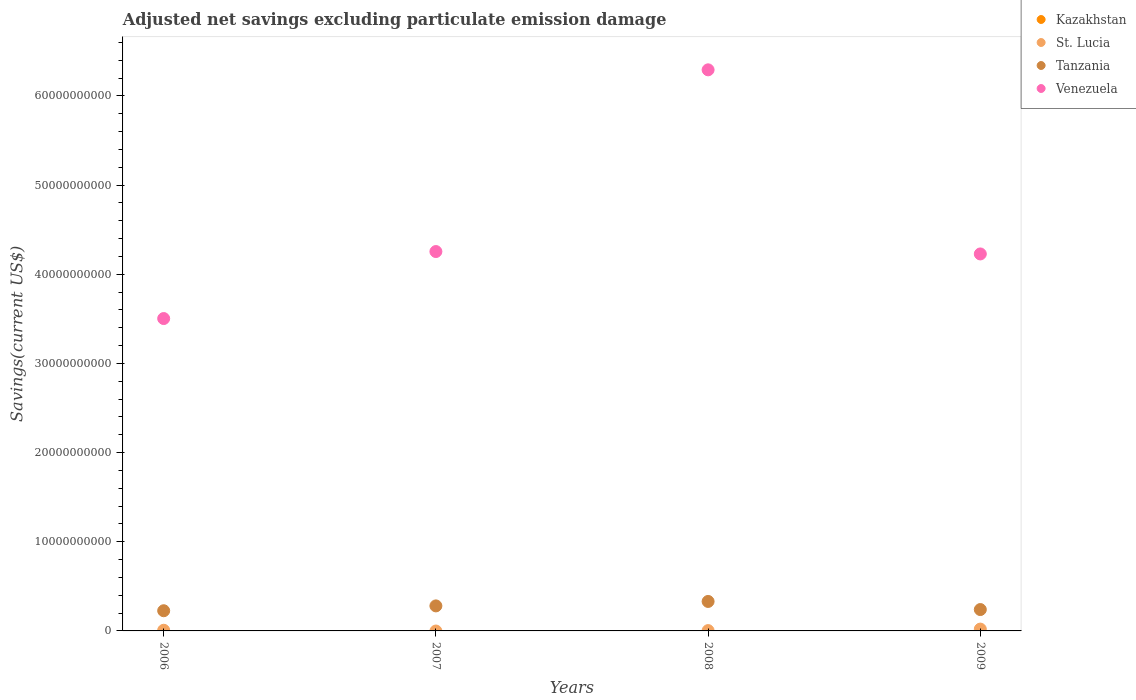How many different coloured dotlines are there?
Offer a very short reply. 3. Is the number of dotlines equal to the number of legend labels?
Offer a very short reply. No. What is the adjusted net savings in St. Lucia in 2008?
Your answer should be compact. 3.58e+07. Across all years, what is the maximum adjusted net savings in Venezuela?
Your answer should be very brief. 6.29e+1. What is the total adjusted net savings in Tanzania in the graph?
Provide a short and direct response. 1.08e+1. What is the difference between the adjusted net savings in Tanzania in 2007 and that in 2008?
Offer a terse response. -4.98e+08. What is the difference between the adjusted net savings in Tanzania in 2009 and the adjusted net savings in St. Lucia in 2008?
Your answer should be very brief. 2.36e+09. What is the average adjusted net savings in St. Lucia per year?
Your response must be concise. 7.88e+07. In the year 2006, what is the difference between the adjusted net savings in Tanzania and adjusted net savings in St. Lucia?
Provide a succinct answer. 2.19e+09. What is the ratio of the adjusted net savings in Venezuela in 2006 to that in 2007?
Make the answer very short. 0.82. Is the adjusted net savings in St. Lucia in 2006 less than that in 2008?
Your answer should be compact. No. What is the difference between the highest and the second highest adjusted net savings in Tanzania?
Provide a short and direct response. 4.98e+08. What is the difference between the highest and the lowest adjusted net savings in St. Lucia?
Offer a terse response. 2.05e+08. Is it the case that in every year, the sum of the adjusted net savings in Kazakhstan and adjusted net savings in Venezuela  is greater than the sum of adjusted net savings in Tanzania and adjusted net savings in St. Lucia?
Provide a succinct answer. Yes. Is the adjusted net savings in Kazakhstan strictly less than the adjusted net savings in St. Lucia over the years?
Your answer should be compact. Yes. How many dotlines are there?
Your response must be concise. 3. What is the difference between two consecutive major ticks on the Y-axis?
Provide a succinct answer. 1.00e+1. Does the graph contain any zero values?
Give a very brief answer. Yes. Where does the legend appear in the graph?
Keep it short and to the point. Top right. How many legend labels are there?
Offer a very short reply. 4. How are the legend labels stacked?
Offer a terse response. Vertical. What is the title of the graph?
Keep it short and to the point. Adjusted net savings excluding particulate emission damage. What is the label or title of the X-axis?
Your answer should be compact. Years. What is the label or title of the Y-axis?
Provide a succinct answer. Savings(current US$). What is the Savings(current US$) of St. Lucia in 2006?
Provide a succinct answer. 7.46e+07. What is the Savings(current US$) in Tanzania in 2006?
Give a very brief answer. 2.26e+09. What is the Savings(current US$) of Venezuela in 2006?
Provide a short and direct response. 3.50e+1. What is the Savings(current US$) in Tanzania in 2007?
Give a very brief answer. 2.81e+09. What is the Savings(current US$) in Venezuela in 2007?
Make the answer very short. 4.25e+1. What is the Savings(current US$) of Kazakhstan in 2008?
Provide a short and direct response. 0. What is the Savings(current US$) in St. Lucia in 2008?
Give a very brief answer. 3.58e+07. What is the Savings(current US$) in Tanzania in 2008?
Your answer should be compact. 3.30e+09. What is the Savings(current US$) in Venezuela in 2008?
Your response must be concise. 6.29e+1. What is the Savings(current US$) in St. Lucia in 2009?
Provide a short and direct response. 2.05e+08. What is the Savings(current US$) in Tanzania in 2009?
Your response must be concise. 2.40e+09. What is the Savings(current US$) in Venezuela in 2009?
Your answer should be compact. 4.23e+1. Across all years, what is the maximum Savings(current US$) in St. Lucia?
Give a very brief answer. 2.05e+08. Across all years, what is the maximum Savings(current US$) in Tanzania?
Ensure brevity in your answer.  3.30e+09. Across all years, what is the maximum Savings(current US$) in Venezuela?
Offer a terse response. 6.29e+1. Across all years, what is the minimum Savings(current US$) of St. Lucia?
Your answer should be very brief. 0. Across all years, what is the minimum Savings(current US$) of Tanzania?
Provide a short and direct response. 2.26e+09. Across all years, what is the minimum Savings(current US$) of Venezuela?
Offer a very short reply. 3.50e+1. What is the total Savings(current US$) in Kazakhstan in the graph?
Offer a terse response. 0. What is the total Savings(current US$) in St. Lucia in the graph?
Keep it short and to the point. 3.15e+08. What is the total Savings(current US$) in Tanzania in the graph?
Offer a very short reply. 1.08e+1. What is the total Savings(current US$) in Venezuela in the graph?
Keep it short and to the point. 1.83e+11. What is the difference between the Savings(current US$) of Tanzania in 2006 and that in 2007?
Make the answer very short. -5.43e+08. What is the difference between the Savings(current US$) of Venezuela in 2006 and that in 2007?
Provide a succinct answer. -7.51e+09. What is the difference between the Savings(current US$) in St. Lucia in 2006 and that in 2008?
Your answer should be very brief. 3.88e+07. What is the difference between the Savings(current US$) in Tanzania in 2006 and that in 2008?
Keep it short and to the point. -1.04e+09. What is the difference between the Savings(current US$) of Venezuela in 2006 and that in 2008?
Offer a very short reply. -2.79e+1. What is the difference between the Savings(current US$) in St. Lucia in 2006 and that in 2009?
Make the answer very short. -1.30e+08. What is the difference between the Savings(current US$) in Tanzania in 2006 and that in 2009?
Offer a very short reply. -1.32e+08. What is the difference between the Savings(current US$) of Venezuela in 2006 and that in 2009?
Your answer should be very brief. -7.25e+09. What is the difference between the Savings(current US$) of Tanzania in 2007 and that in 2008?
Offer a terse response. -4.98e+08. What is the difference between the Savings(current US$) of Venezuela in 2007 and that in 2008?
Keep it short and to the point. -2.04e+1. What is the difference between the Savings(current US$) of Tanzania in 2007 and that in 2009?
Your answer should be compact. 4.11e+08. What is the difference between the Savings(current US$) in Venezuela in 2007 and that in 2009?
Your response must be concise. 2.69e+08. What is the difference between the Savings(current US$) of St. Lucia in 2008 and that in 2009?
Offer a terse response. -1.69e+08. What is the difference between the Savings(current US$) in Tanzania in 2008 and that in 2009?
Your answer should be very brief. 9.09e+08. What is the difference between the Savings(current US$) of Venezuela in 2008 and that in 2009?
Offer a terse response. 2.06e+1. What is the difference between the Savings(current US$) in St. Lucia in 2006 and the Savings(current US$) in Tanzania in 2007?
Give a very brief answer. -2.73e+09. What is the difference between the Savings(current US$) in St. Lucia in 2006 and the Savings(current US$) in Venezuela in 2007?
Your answer should be compact. -4.25e+1. What is the difference between the Savings(current US$) of Tanzania in 2006 and the Savings(current US$) of Venezuela in 2007?
Offer a terse response. -4.03e+1. What is the difference between the Savings(current US$) in St. Lucia in 2006 and the Savings(current US$) in Tanzania in 2008?
Ensure brevity in your answer.  -3.23e+09. What is the difference between the Savings(current US$) in St. Lucia in 2006 and the Savings(current US$) in Venezuela in 2008?
Make the answer very short. -6.29e+1. What is the difference between the Savings(current US$) of Tanzania in 2006 and the Savings(current US$) of Venezuela in 2008?
Offer a terse response. -6.07e+1. What is the difference between the Savings(current US$) of St. Lucia in 2006 and the Savings(current US$) of Tanzania in 2009?
Make the answer very short. -2.32e+09. What is the difference between the Savings(current US$) in St. Lucia in 2006 and the Savings(current US$) in Venezuela in 2009?
Your response must be concise. -4.22e+1. What is the difference between the Savings(current US$) in Tanzania in 2006 and the Savings(current US$) in Venezuela in 2009?
Your answer should be very brief. -4.00e+1. What is the difference between the Savings(current US$) in Tanzania in 2007 and the Savings(current US$) in Venezuela in 2008?
Provide a succinct answer. -6.01e+1. What is the difference between the Savings(current US$) in Tanzania in 2007 and the Savings(current US$) in Venezuela in 2009?
Offer a terse response. -3.95e+1. What is the difference between the Savings(current US$) of St. Lucia in 2008 and the Savings(current US$) of Tanzania in 2009?
Your answer should be very brief. -2.36e+09. What is the difference between the Savings(current US$) of St. Lucia in 2008 and the Savings(current US$) of Venezuela in 2009?
Your response must be concise. -4.22e+1. What is the difference between the Savings(current US$) of Tanzania in 2008 and the Savings(current US$) of Venezuela in 2009?
Ensure brevity in your answer.  -3.90e+1. What is the average Savings(current US$) in St. Lucia per year?
Ensure brevity in your answer.  7.88e+07. What is the average Savings(current US$) of Tanzania per year?
Your answer should be compact. 2.69e+09. What is the average Savings(current US$) of Venezuela per year?
Your response must be concise. 4.57e+1. In the year 2006, what is the difference between the Savings(current US$) of St. Lucia and Savings(current US$) of Tanzania?
Offer a very short reply. -2.19e+09. In the year 2006, what is the difference between the Savings(current US$) in St. Lucia and Savings(current US$) in Venezuela?
Make the answer very short. -3.50e+1. In the year 2006, what is the difference between the Savings(current US$) in Tanzania and Savings(current US$) in Venezuela?
Give a very brief answer. -3.28e+1. In the year 2007, what is the difference between the Savings(current US$) of Tanzania and Savings(current US$) of Venezuela?
Your response must be concise. -3.97e+1. In the year 2008, what is the difference between the Savings(current US$) in St. Lucia and Savings(current US$) in Tanzania?
Offer a terse response. -3.27e+09. In the year 2008, what is the difference between the Savings(current US$) of St. Lucia and Savings(current US$) of Venezuela?
Ensure brevity in your answer.  -6.29e+1. In the year 2008, what is the difference between the Savings(current US$) of Tanzania and Savings(current US$) of Venezuela?
Your answer should be very brief. -5.96e+1. In the year 2009, what is the difference between the Savings(current US$) of St. Lucia and Savings(current US$) of Tanzania?
Your answer should be very brief. -2.19e+09. In the year 2009, what is the difference between the Savings(current US$) in St. Lucia and Savings(current US$) in Venezuela?
Provide a short and direct response. -4.21e+1. In the year 2009, what is the difference between the Savings(current US$) in Tanzania and Savings(current US$) in Venezuela?
Offer a very short reply. -3.99e+1. What is the ratio of the Savings(current US$) of Tanzania in 2006 to that in 2007?
Offer a terse response. 0.81. What is the ratio of the Savings(current US$) in Venezuela in 2006 to that in 2007?
Offer a very short reply. 0.82. What is the ratio of the Savings(current US$) of St. Lucia in 2006 to that in 2008?
Make the answer very short. 2.08. What is the ratio of the Savings(current US$) of Tanzania in 2006 to that in 2008?
Ensure brevity in your answer.  0.69. What is the ratio of the Savings(current US$) in Venezuela in 2006 to that in 2008?
Your response must be concise. 0.56. What is the ratio of the Savings(current US$) of St. Lucia in 2006 to that in 2009?
Your answer should be very brief. 0.36. What is the ratio of the Savings(current US$) in Tanzania in 2006 to that in 2009?
Keep it short and to the point. 0.94. What is the ratio of the Savings(current US$) in Venezuela in 2006 to that in 2009?
Offer a very short reply. 0.83. What is the ratio of the Savings(current US$) in Tanzania in 2007 to that in 2008?
Your answer should be very brief. 0.85. What is the ratio of the Savings(current US$) in Venezuela in 2007 to that in 2008?
Provide a short and direct response. 0.68. What is the ratio of the Savings(current US$) of Tanzania in 2007 to that in 2009?
Keep it short and to the point. 1.17. What is the ratio of the Savings(current US$) of Venezuela in 2007 to that in 2009?
Ensure brevity in your answer.  1.01. What is the ratio of the Savings(current US$) of St. Lucia in 2008 to that in 2009?
Your answer should be compact. 0.18. What is the ratio of the Savings(current US$) of Tanzania in 2008 to that in 2009?
Offer a very short reply. 1.38. What is the ratio of the Savings(current US$) of Venezuela in 2008 to that in 2009?
Your answer should be very brief. 1.49. What is the difference between the highest and the second highest Savings(current US$) of St. Lucia?
Ensure brevity in your answer.  1.30e+08. What is the difference between the highest and the second highest Savings(current US$) of Tanzania?
Give a very brief answer. 4.98e+08. What is the difference between the highest and the second highest Savings(current US$) of Venezuela?
Give a very brief answer. 2.04e+1. What is the difference between the highest and the lowest Savings(current US$) of St. Lucia?
Ensure brevity in your answer.  2.05e+08. What is the difference between the highest and the lowest Savings(current US$) of Tanzania?
Make the answer very short. 1.04e+09. What is the difference between the highest and the lowest Savings(current US$) of Venezuela?
Your response must be concise. 2.79e+1. 